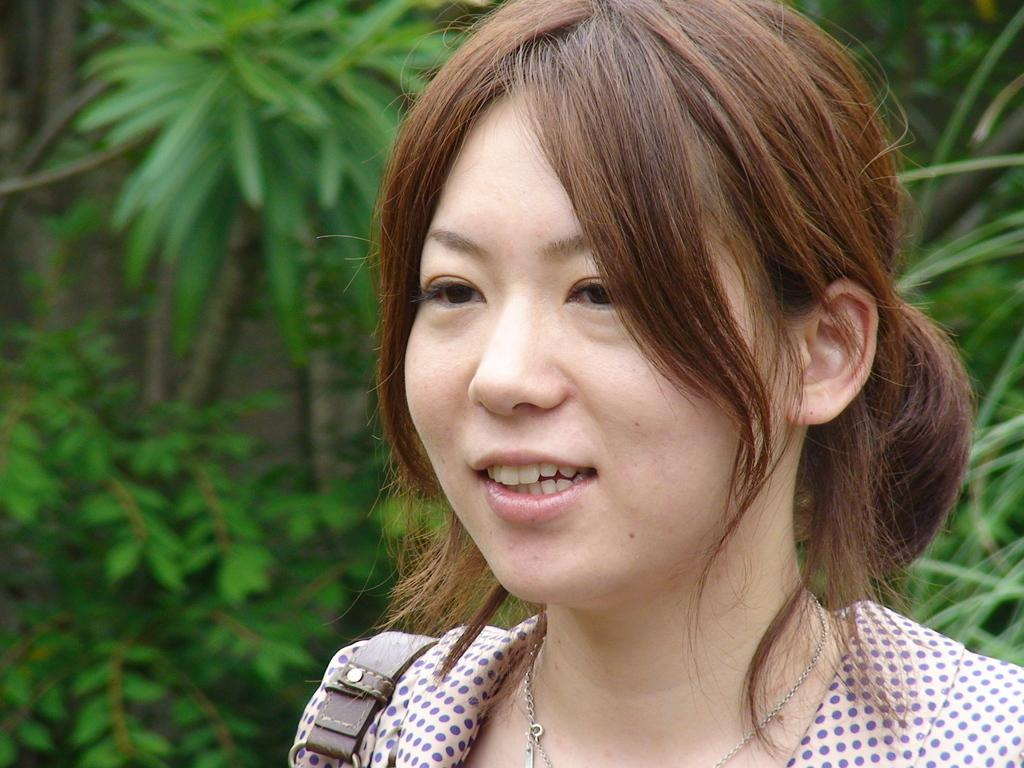Who is the main subject in the image? There is a lady in the center of the image. What can be seen in the background of the image? There are trees in the background of the image. What type of pig is visible in the image? There is no pig present in the image. What are the lady's hobbies, as depicted in the image? The image does not provide information about the lady's hobbies. Is the lady wearing a veil in the image? There is no indication of a veil in the image. 